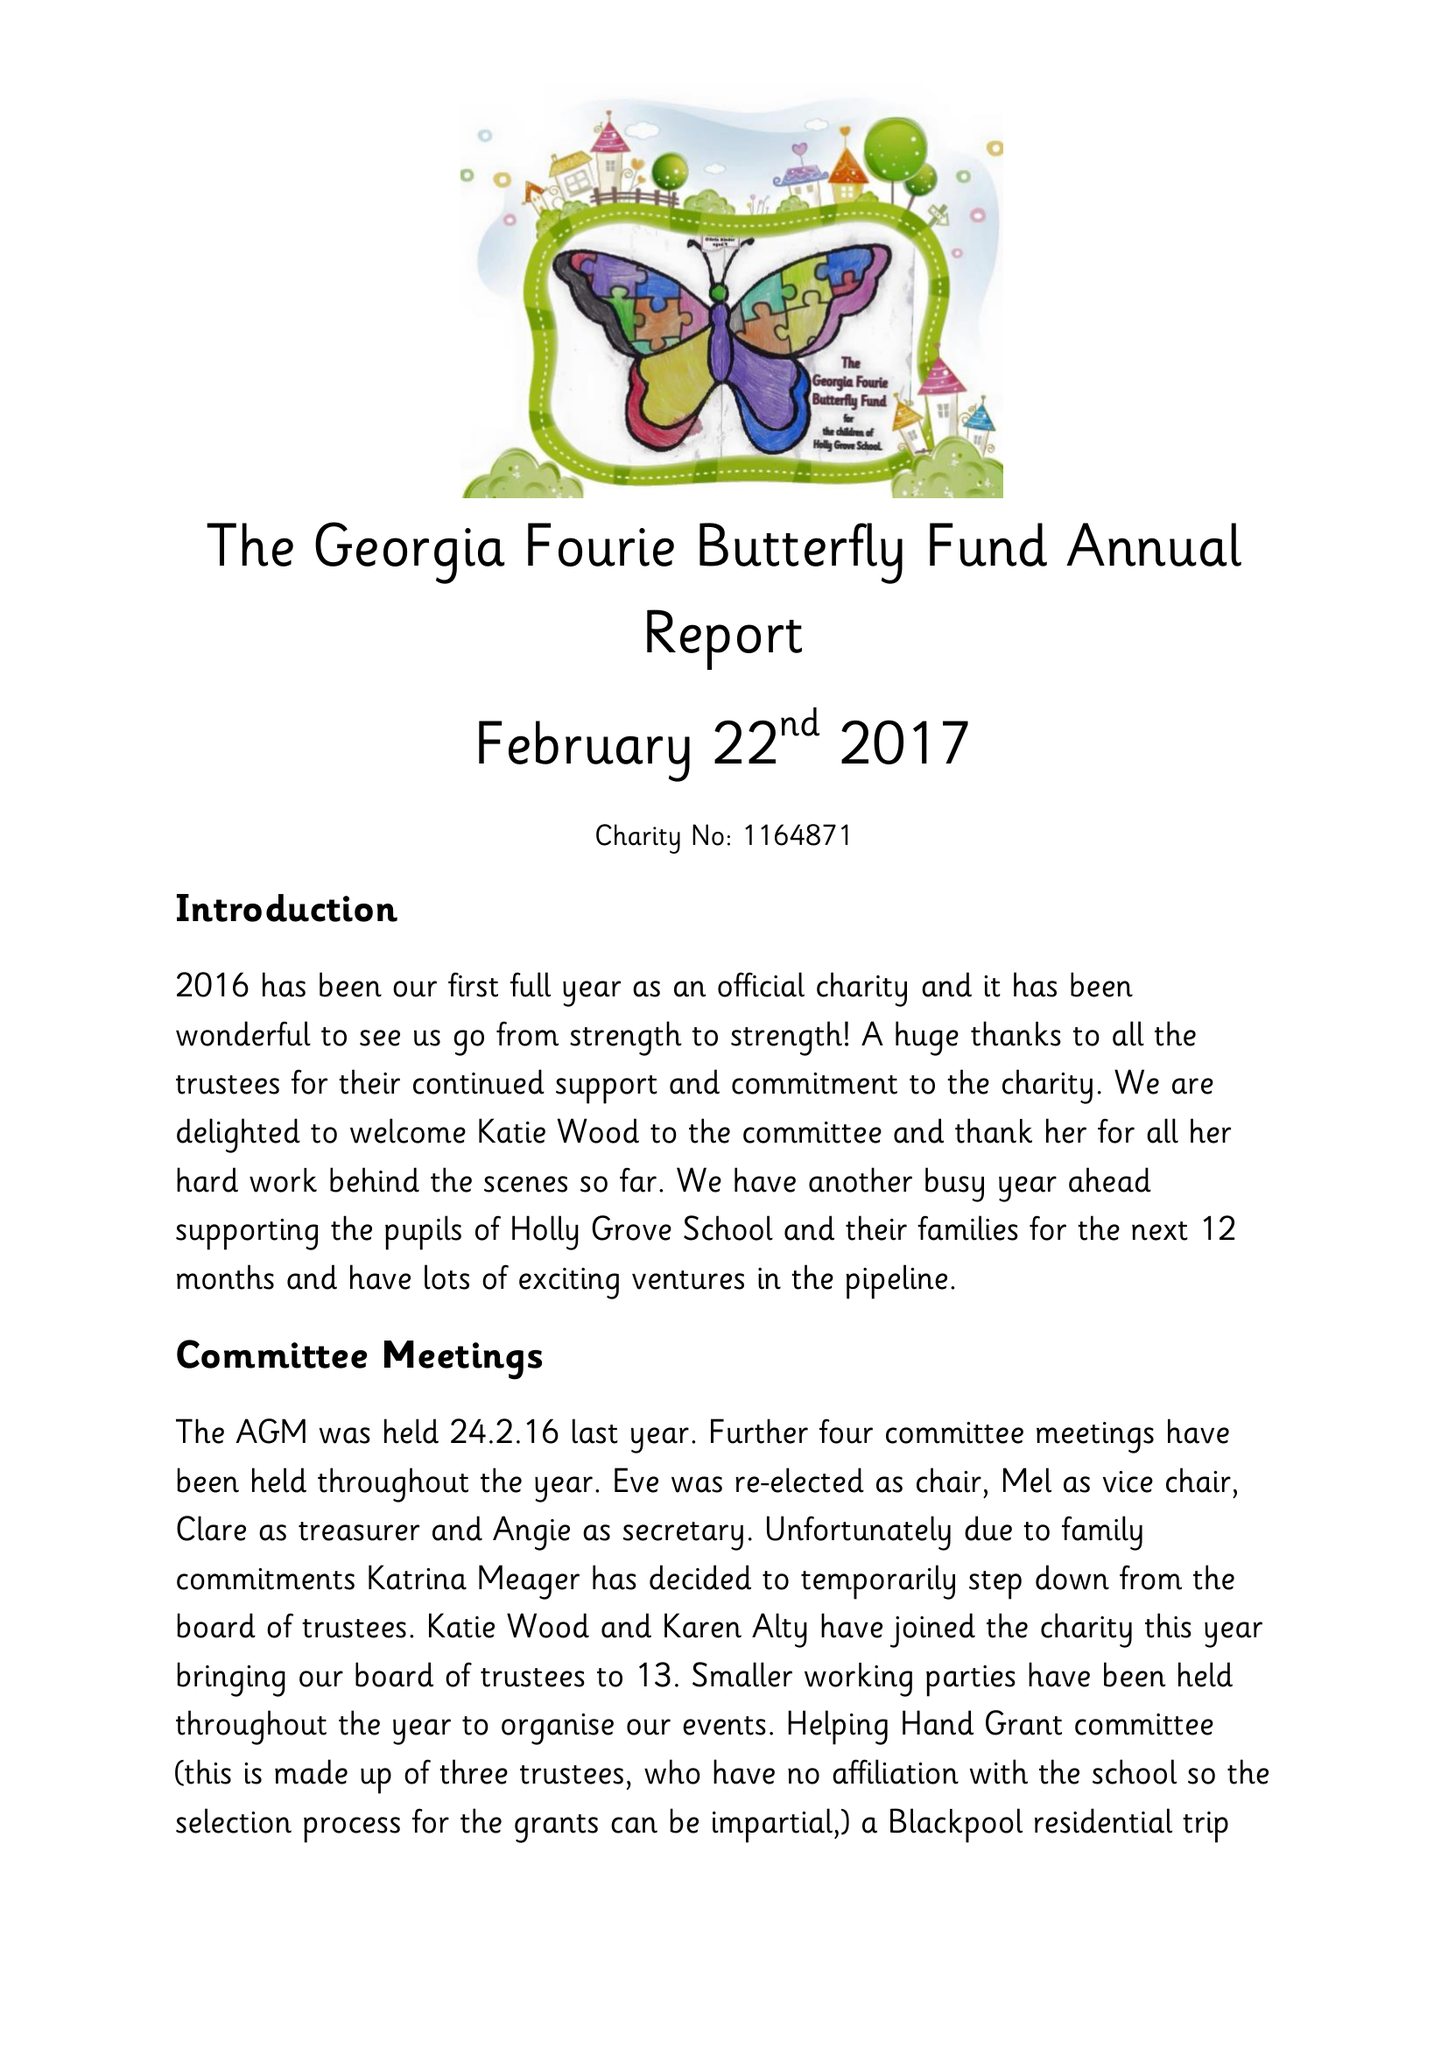What is the value for the address__street_line?
Answer the question using a single word or phrase. BARDEN LANE 